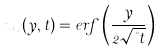<formula> <loc_0><loc_0><loc_500><loc_500>u _ { x } ( y , t ) = e r f \left ( \frac { y } { 2 \sqrt { \nu t } } \right )</formula> 